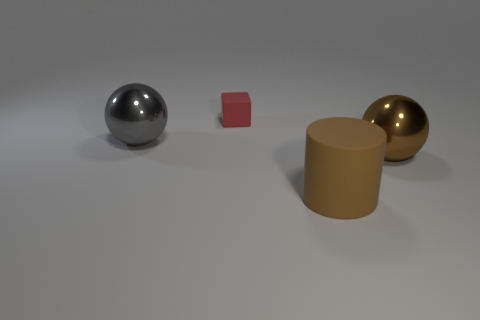What materials are represented by the objects in this image? The materials depicted by the objects appear to resemble metal for the spherical object on the left, plastic for the small cube in the middle, and perhaps polished wood or metal for the cylindrical and spherical objects on the right. 